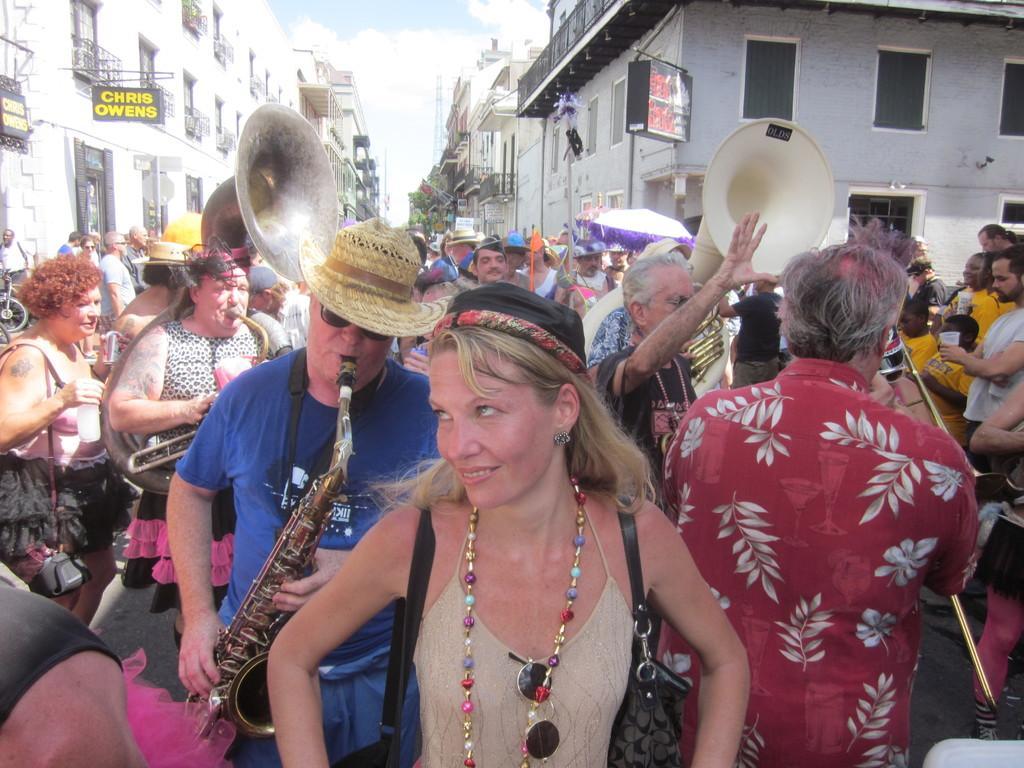How would you summarize this image in a sentence or two? In this picture I can see group of people standing, some people holding the musical instruments, and there are boards, buildings, trees, and in the background there is sky. 